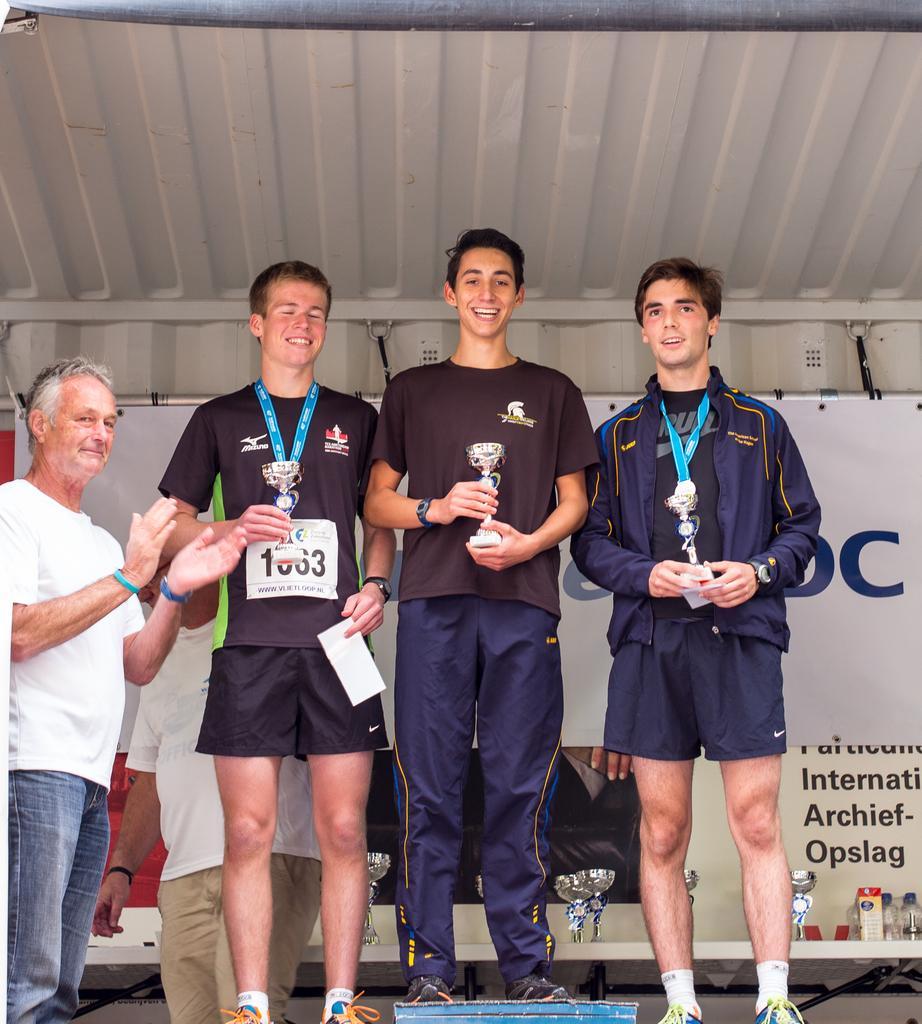Describe this image in one or two sentences. In this image I can see four persons standing, in front the three persons are holding three shields in their hands and the person at left wearing black color dress and holding a paper. Background I can see a board in white color. 